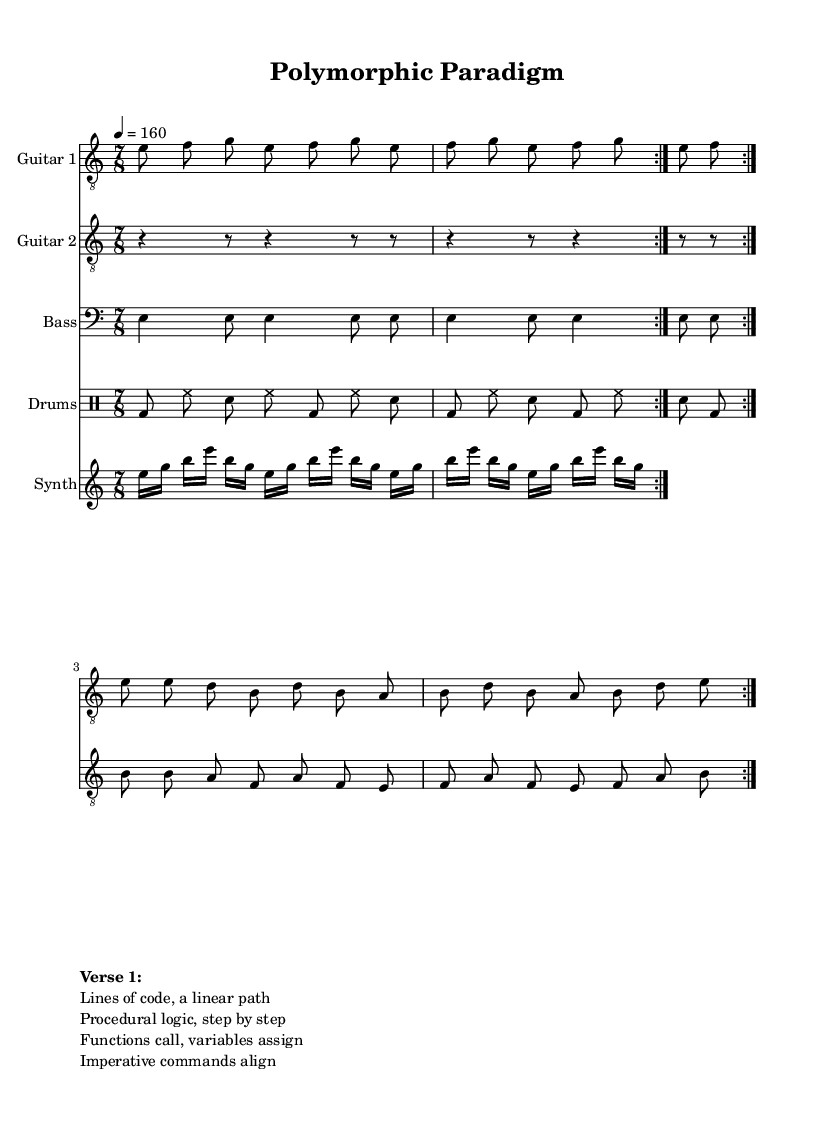What is the key signature of this music? The key signature is E Phrygian, which contains no sharps or flats. Phrygian is characterized by the flat second degree, which can be observed in the notes presented.
Answer: E Phrygian What is the time signature of this music? The time signature shown in the score is 7/8, indicating there are seven eighth notes per measure. This can be identified at the beginning of the sheet music, which states the rhythmic structure.
Answer: 7/8 What is the tempo marking for this piece? The tempo marking provided in the score is 4 = 160, indicating the quarter note gets a beat of 160 beats per minute. This is clearly noted in the tempo indication section of the score.
Answer: 160 How many times is the main riff repeated? The main riff is repeated twice, as indicated by the "repeat volta 2" directive in the guitar parts. This suggests that the entire section between the repeats is performed two times.
Answer: 2 What is the predominant style of this music piece? The predominant style of this music piece is progressive metal. This can be inferred from the complex time signature, the use of multiple guitar parts, and the overall arrangement, typical of progressive metal music.
Answer: Progressive metal What type of rhythmic pattern is used in the drum part? The drum part utilizes a mix of bass drum, hi-hat, and snare percussion in a syncopated rhythm typical of metal genres. This is evident from the drum notation which incorporates varied placements of these elements within the measures.
Answer: Syncopated What thematic element do the lyrics of Verse 1 refer to? The lyrics of Verse 1 refer to coding and programming concepts, specifically procedural logic and command execution, reflecting a theme linked to programming languages. This can be inferred by analyzing the text provided after the notation in the score.
Answer: Programming languages 